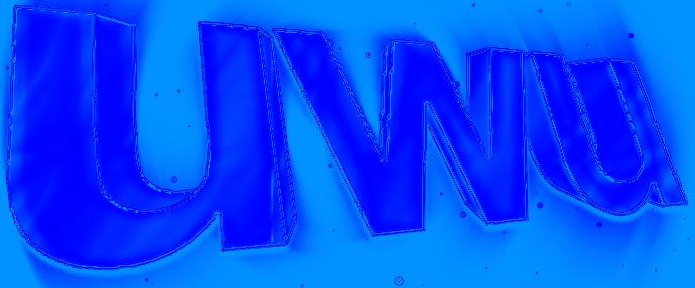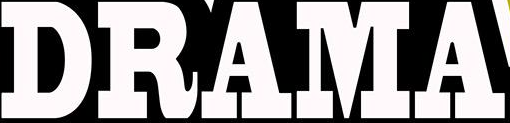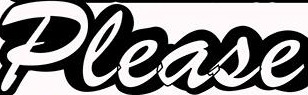Read the text content from these images in order, separated by a semicolon. uwu; DRAMA; Please 